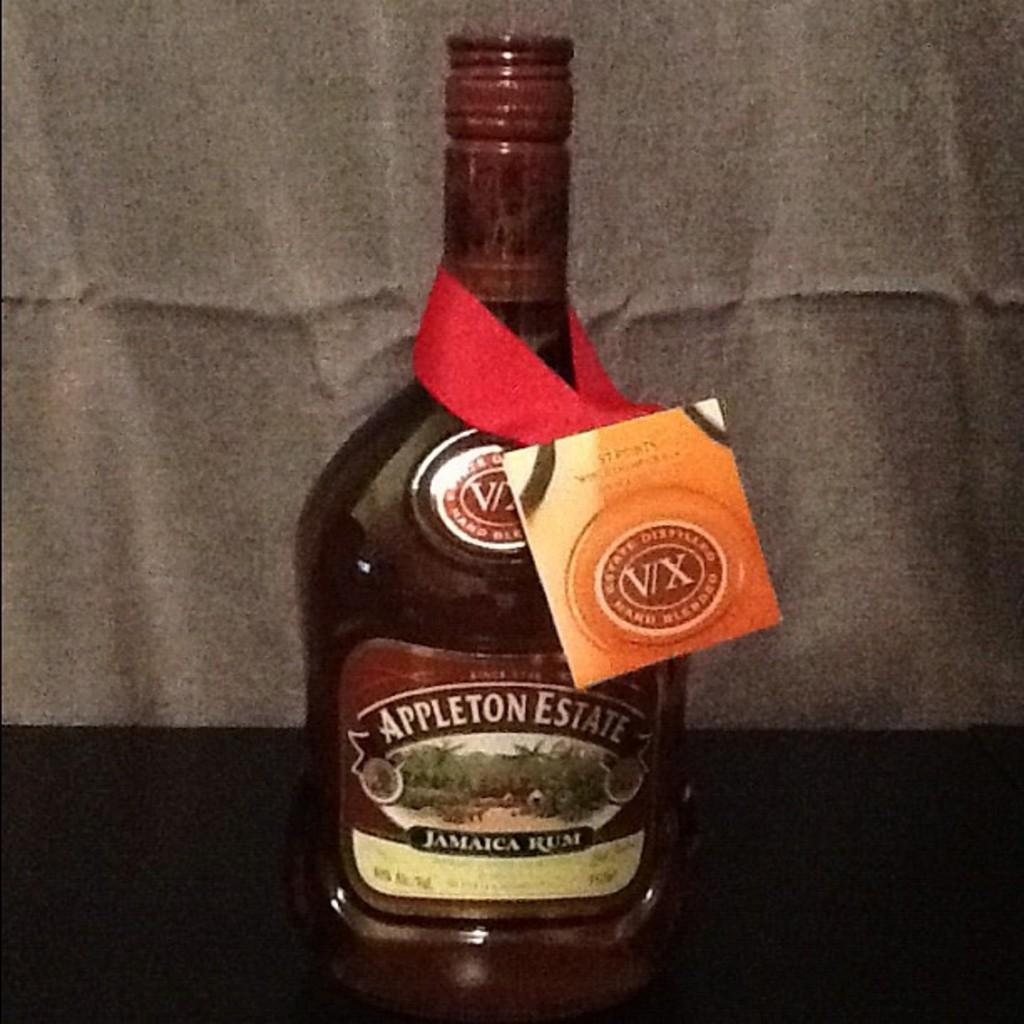What is the main object in the middle of the image? There is a bottle in the middle of the image. What can be seen on the bottle? The bottle has stickers on it and a badge. Where is the bottle placed? The bottle is placed on a surface. What color is the cloth in the background? The cloth in the background is white. How many cakes are displayed on the table in the image? There are no cakes present in the image; it features a bottle with stickers and a badge. What type of creature is shown sleeping on the bed in the image? There is no bed or creature present in the image; it only shows a bottle with stickers and a badge on a surface. 